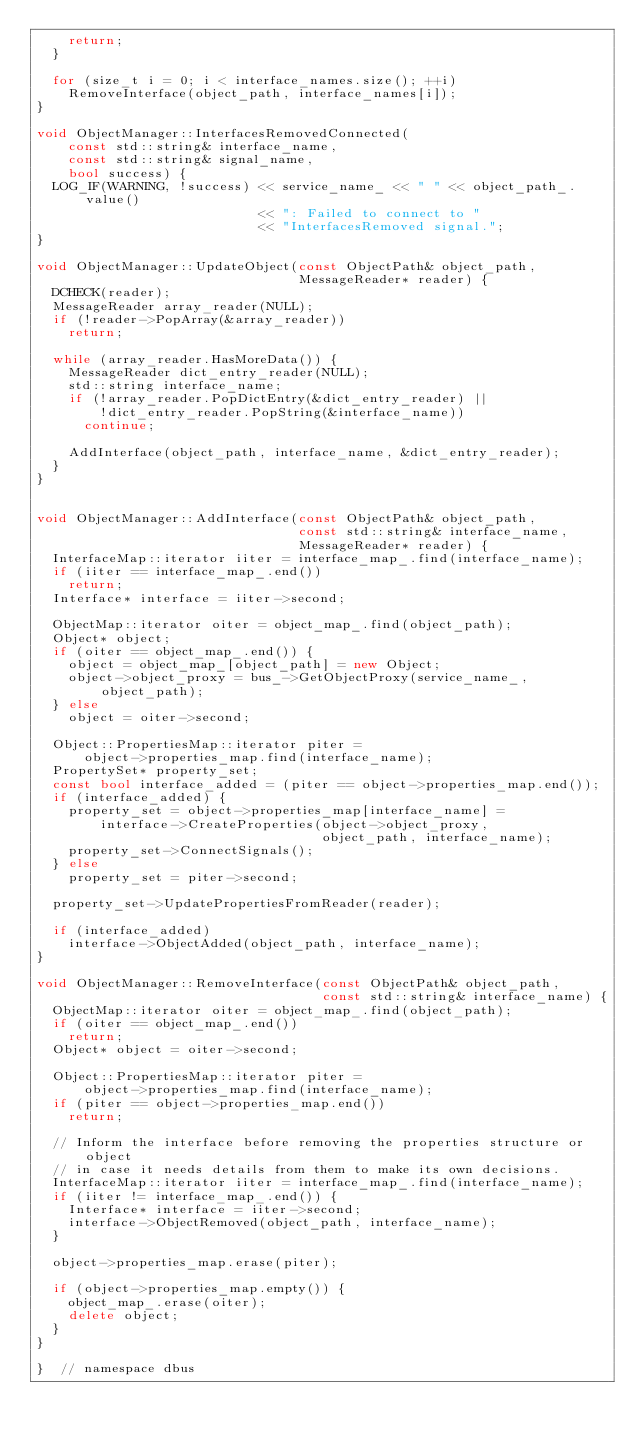<code> <loc_0><loc_0><loc_500><loc_500><_C++_>    return;
  }

  for (size_t i = 0; i < interface_names.size(); ++i)
    RemoveInterface(object_path, interface_names[i]);
}

void ObjectManager::InterfacesRemovedConnected(
    const std::string& interface_name,
    const std::string& signal_name,
    bool success) {
  LOG_IF(WARNING, !success) << service_name_ << " " << object_path_.value()
                            << ": Failed to connect to "
                            << "InterfacesRemoved signal.";
}

void ObjectManager::UpdateObject(const ObjectPath& object_path,
                                 MessageReader* reader) {
  DCHECK(reader);
  MessageReader array_reader(NULL);
  if (!reader->PopArray(&array_reader))
    return;

  while (array_reader.HasMoreData()) {
    MessageReader dict_entry_reader(NULL);
    std::string interface_name;
    if (!array_reader.PopDictEntry(&dict_entry_reader) ||
        !dict_entry_reader.PopString(&interface_name))
      continue;

    AddInterface(object_path, interface_name, &dict_entry_reader);
  }
}


void ObjectManager::AddInterface(const ObjectPath& object_path,
                                 const std::string& interface_name,
                                 MessageReader* reader) {
  InterfaceMap::iterator iiter = interface_map_.find(interface_name);
  if (iiter == interface_map_.end())
    return;
  Interface* interface = iiter->second;

  ObjectMap::iterator oiter = object_map_.find(object_path);
  Object* object;
  if (oiter == object_map_.end()) {
    object = object_map_[object_path] = new Object;
    object->object_proxy = bus_->GetObjectProxy(service_name_, object_path);
  } else
    object = oiter->second;

  Object::PropertiesMap::iterator piter =
      object->properties_map.find(interface_name);
  PropertySet* property_set;
  const bool interface_added = (piter == object->properties_map.end());
  if (interface_added) {
    property_set = object->properties_map[interface_name] =
        interface->CreateProperties(object->object_proxy,
                                    object_path, interface_name);
    property_set->ConnectSignals();
  } else
    property_set = piter->second;

  property_set->UpdatePropertiesFromReader(reader);

  if (interface_added)
    interface->ObjectAdded(object_path, interface_name);
}

void ObjectManager::RemoveInterface(const ObjectPath& object_path,
                                    const std::string& interface_name) {
  ObjectMap::iterator oiter = object_map_.find(object_path);
  if (oiter == object_map_.end())
    return;
  Object* object = oiter->second;

  Object::PropertiesMap::iterator piter =
      object->properties_map.find(interface_name);
  if (piter == object->properties_map.end())
    return;

  // Inform the interface before removing the properties structure or object
  // in case it needs details from them to make its own decisions.
  InterfaceMap::iterator iiter = interface_map_.find(interface_name);
  if (iiter != interface_map_.end()) {
    Interface* interface = iiter->second;
    interface->ObjectRemoved(object_path, interface_name);
  }

  object->properties_map.erase(piter);

  if (object->properties_map.empty()) {
    object_map_.erase(oiter);
    delete object;
  }
}

}  // namespace dbus
</code> 